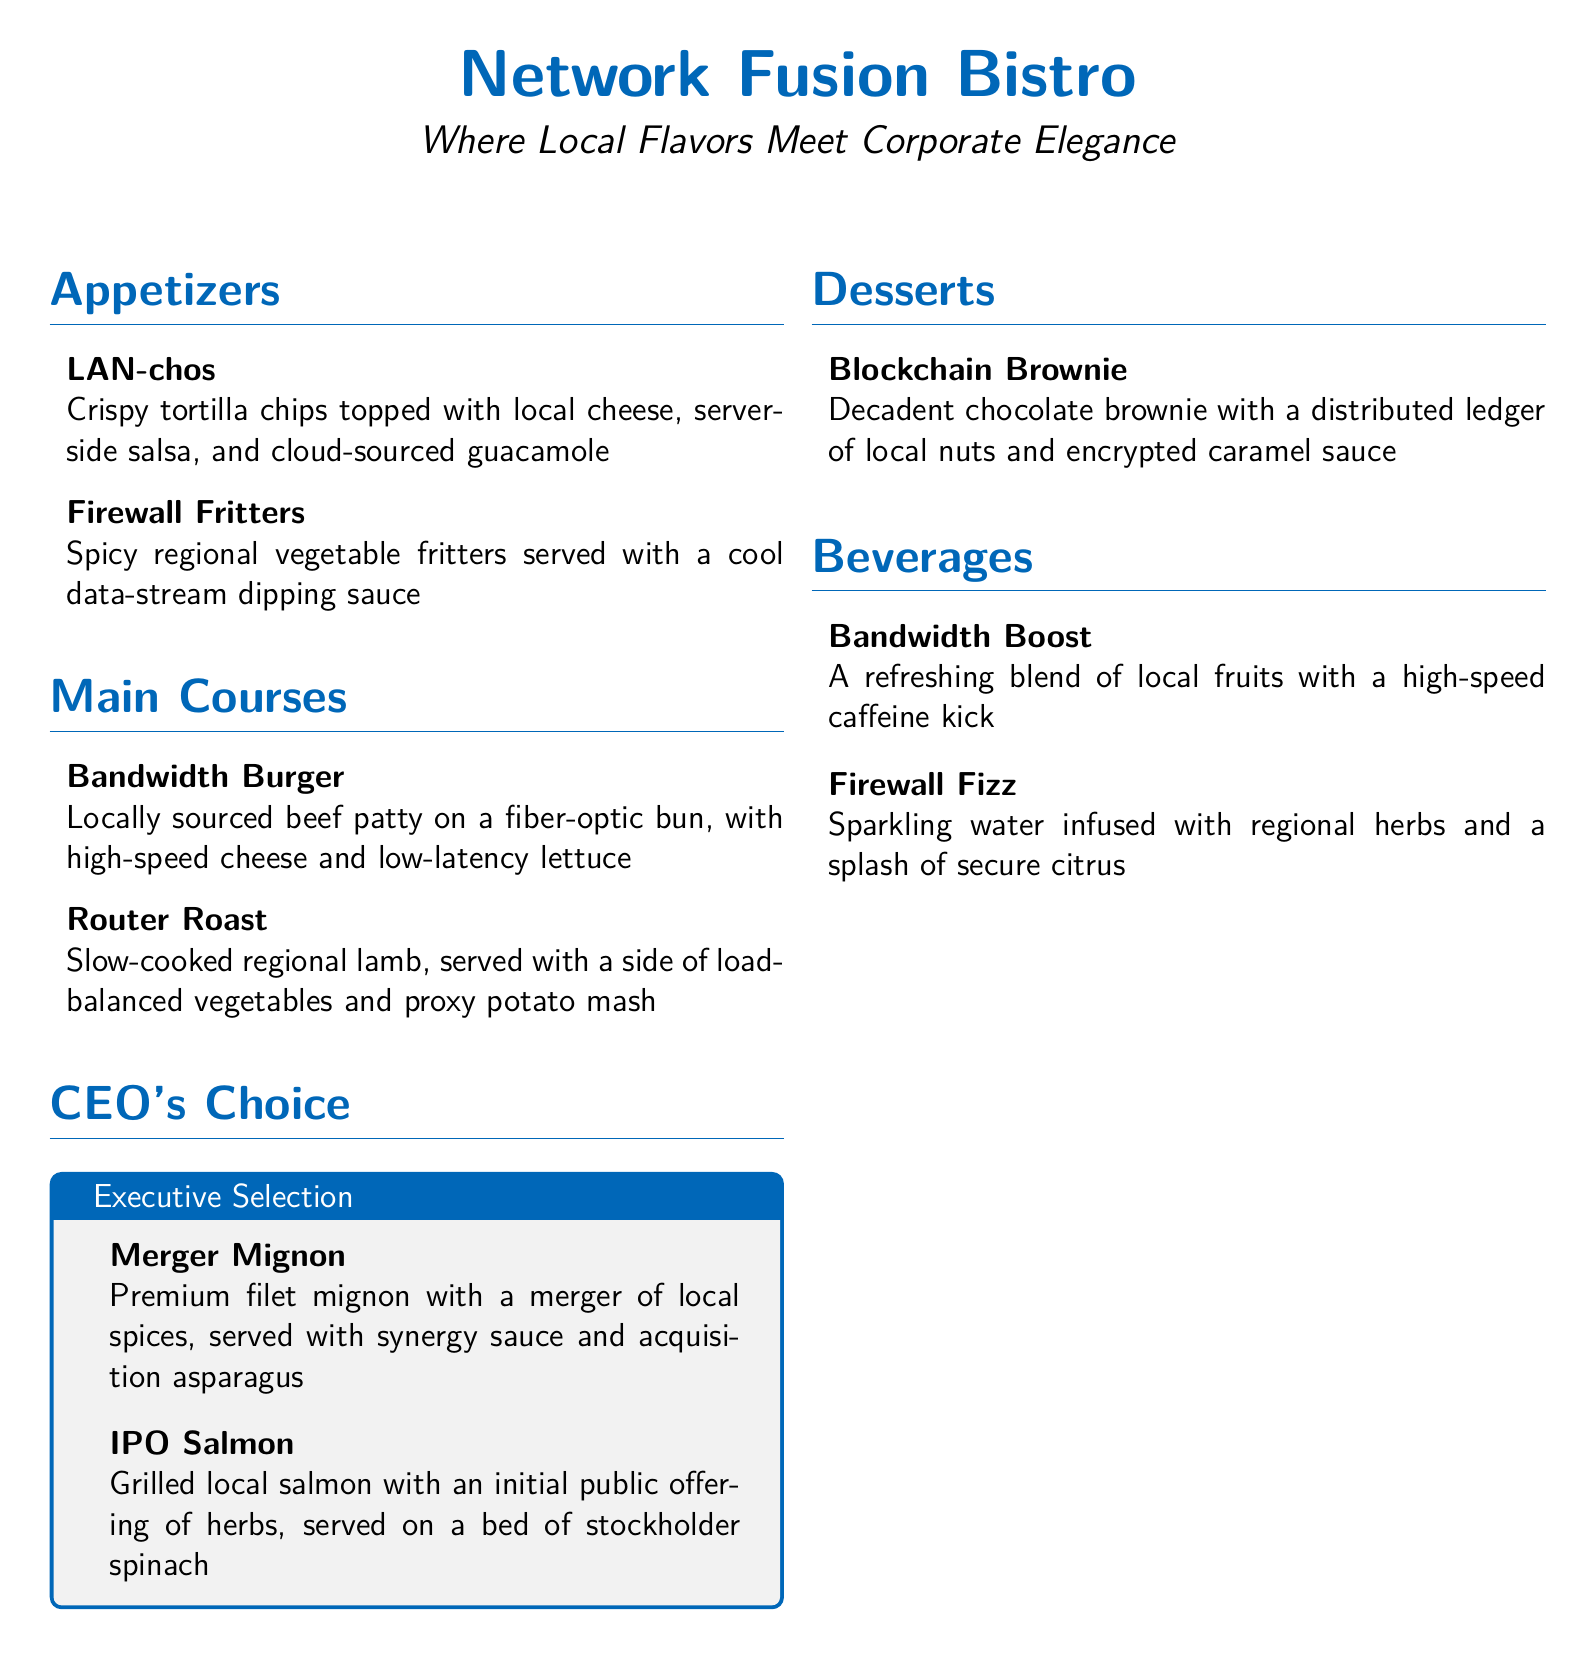What is the name of the restaurant? The name of the restaurant is prominently displayed at the top of the document.
Answer: Network Fusion Bistro How many appetizers are listed? The document section for appetizers includes a specific number of items.
Answer: 2 What is the name of the dessert? The dessert section includes one specific item that is named in the document.
Answer: Blockchain Brownie What main course features local salmon? This refers to a specific dish described in the "CEO's Choice" section.
Answer: IPO Salmon What type of beverage is Bandwidth Boost? The beverage section describes Bandwidth Boost and its key characteristics.
Answer: A refreshing blend of local fruits with a high-speed caffeine kick What accompanies the Merger Mignon? This refers to the side dish or sauce that is served with the specific entrée mentioned.
Answer: Synergy sauce and acquisition asparagus What is unique about Firewall Fritters? The description of Firewall Fritters includes specific flavor attributes indicative of the dish.
Answer: Spicy regional vegetable fritters Which section contains high-end meal options? The document categorizes menu items, and this one is specifically for premium selections.
Answer: CEO's Choice How is the Router Roast prepared? The description outlines the cooking method of the Router Roast dish.
Answer: Slow-cooked 